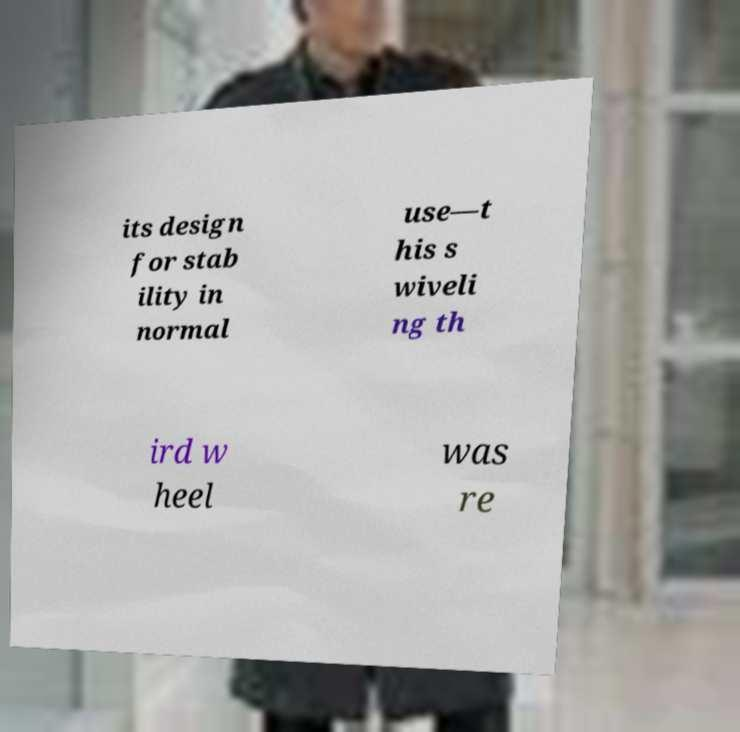Can you read and provide the text displayed in the image?This photo seems to have some interesting text. Can you extract and type it out for me? its design for stab ility in normal use—t his s wiveli ng th ird w heel was re 